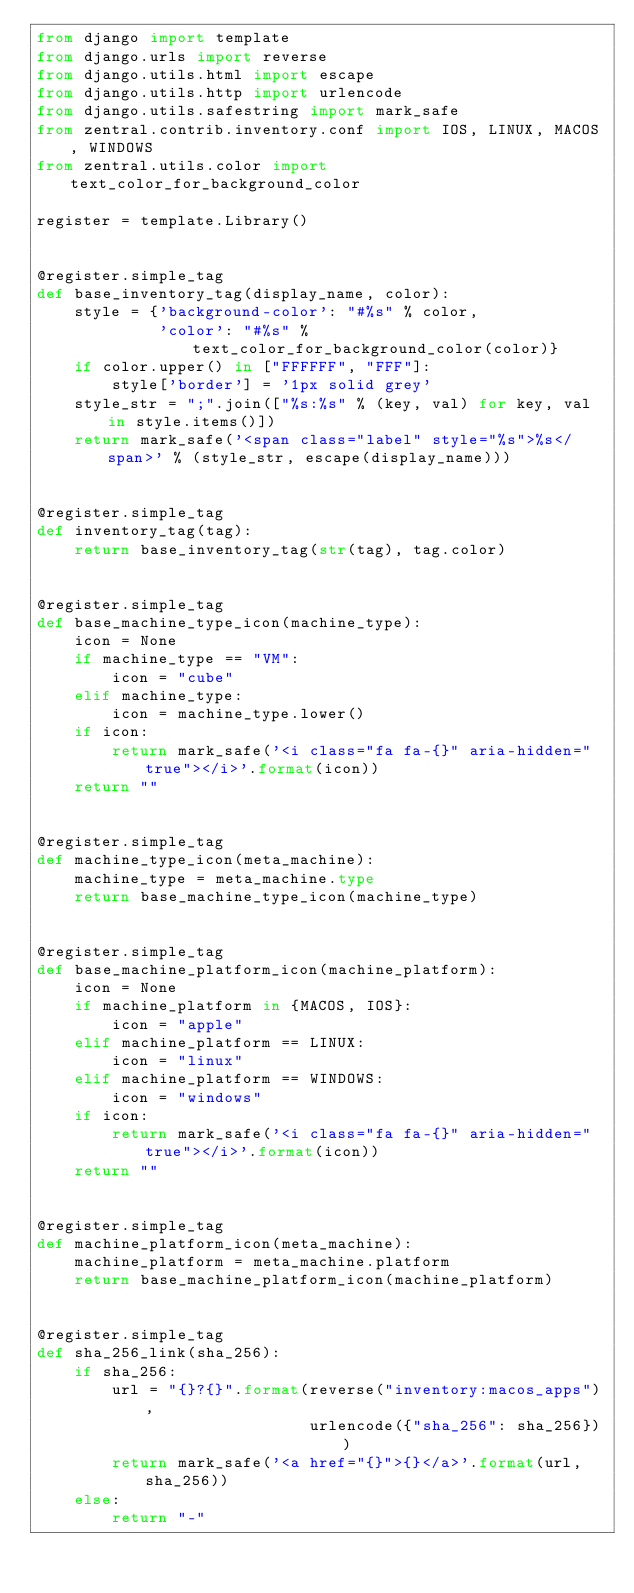<code> <loc_0><loc_0><loc_500><loc_500><_Python_>from django import template
from django.urls import reverse
from django.utils.html import escape
from django.utils.http import urlencode
from django.utils.safestring import mark_safe
from zentral.contrib.inventory.conf import IOS, LINUX, MACOS, WINDOWS
from zentral.utils.color import text_color_for_background_color

register = template.Library()


@register.simple_tag
def base_inventory_tag(display_name, color):
    style = {'background-color': "#%s" % color,
             'color': "#%s" % text_color_for_background_color(color)}
    if color.upper() in ["FFFFFF", "FFF"]:
        style['border'] = '1px solid grey'
    style_str = ";".join(["%s:%s" % (key, val) for key, val in style.items()])
    return mark_safe('<span class="label" style="%s">%s</span>' % (style_str, escape(display_name)))


@register.simple_tag
def inventory_tag(tag):
    return base_inventory_tag(str(tag), tag.color)


@register.simple_tag
def base_machine_type_icon(machine_type):
    icon = None
    if machine_type == "VM":
        icon = "cube"
    elif machine_type:
        icon = machine_type.lower()
    if icon:
        return mark_safe('<i class="fa fa-{}" aria-hidden="true"></i>'.format(icon))
    return ""


@register.simple_tag
def machine_type_icon(meta_machine):
    machine_type = meta_machine.type
    return base_machine_type_icon(machine_type)


@register.simple_tag
def base_machine_platform_icon(machine_platform):
    icon = None
    if machine_platform in {MACOS, IOS}:
        icon = "apple"
    elif machine_platform == LINUX:
        icon = "linux"
    elif machine_platform == WINDOWS:
        icon = "windows"
    if icon:
        return mark_safe('<i class="fa fa-{}" aria-hidden="true"></i>'.format(icon))
    return ""


@register.simple_tag
def machine_platform_icon(meta_machine):
    machine_platform = meta_machine.platform
    return base_machine_platform_icon(machine_platform)


@register.simple_tag
def sha_256_link(sha_256):
    if sha_256:
        url = "{}?{}".format(reverse("inventory:macos_apps"),
                             urlencode({"sha_256": sha_256}))
        return mark_safe('<a href="{}">{}</a>'.format(url, sha_256))
    else:
        return "-"
</code> 